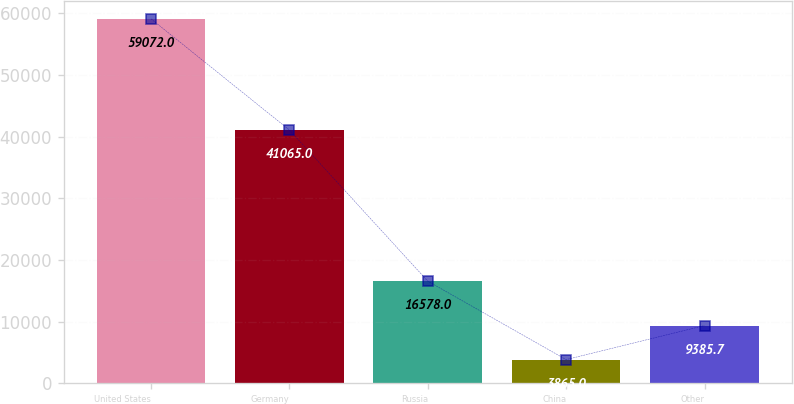<chart> <loc_0><loc_0><loc_500><loc_500><bar_chart><fcel>United States<fcel>Germany<fcel>Russia<fcel>China<fcel>Other<nl><fcel>59072<fcel>41065<fcel>16578<fcel>3865<fcel>9385.7<nl></chart> 